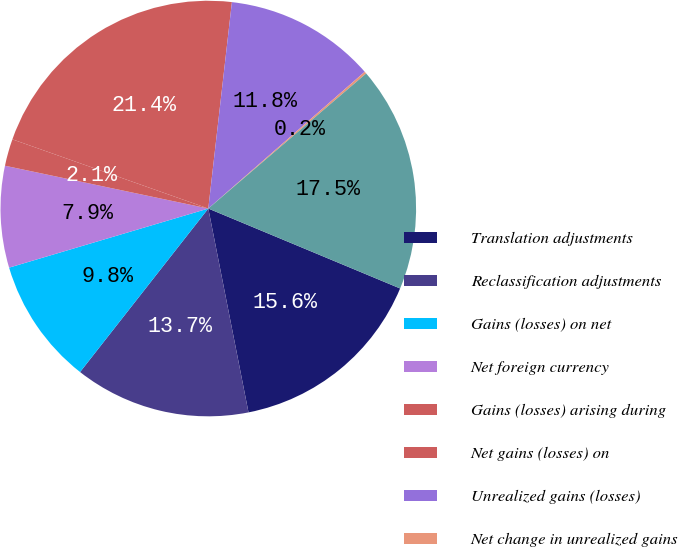Convert chart. <chart><loc_0><loc_0><loc_500><loc_500><pie_chart><fcel>Translation adjustments<fcel>Reclassification adjustments<fcel>Gains (losses) on net<fcel>Net foreign currency<fcel>Gains (losses) arising during<fcel>Net gains (losses) on<fcel>Unrealized gains (losses)<fcel>Net change in unrealized gains<fcel>Net pension and other benefit<nl><fcel>15.61%<fcel>13.68%<fcel>9.82%<fcel>7.89%<fcel>2.1%<fcel>21.4%<fcel>11.75%<fcel>0.17%<fcel>17.54%<nl></chart> 